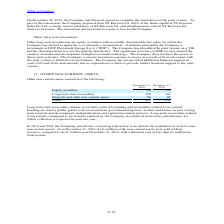According to Stmicroelectronics's financial document, How many non-current assets were sold without recourse as of December 31, 2019? According to the financial document, $131 million. The relevant text states: "some non-current assets. As at December 31, 2019, $131 million of the non-current assets were sold without recourse, compared to $122 million as at December 31, 20..." Also, How many non-current assets were sold without recourse as of December 31, 2018? According to the financial document, $122 million. The relevant text states: "ent assets were sold without recourse, compared to $122 million as at December 31, 2018, with a financial cost of less than $1 million for both periods...." Also, What does Long-term state receivables include? Long-term state receivables include receivables related to funding and receivables related to tax refund.. The document states: "Long-term state receivables include receivables related to funding and receivables related to tax refund. Funding are mainly public grants to be recei..." Also, can you calculate: What is the average Equity securities? To answer this question, I need to perform calculations using the financial data. The calculation is: (23+19) / 2, which equals 21 (in millions). This is based on the information: "Equity securities 23 19 Equity securities 23 19..." The key data points involved are: 19, 23. Also, can you calculate: What is the average Long-term state receivables? To answer this question, I need to perform calculations using the financial data. The calculation is: (358+391) / 2, which equals 374.5 (in millions). This is based on the information: "Long-term state receivables 358 391 Long-term state receivables 358 391..." The key data points involved are: 358, 391. Also, can you calculate: What is the average Deposits and other non-current assets? To answer this question, I need to perform calculations using the financial data. The calculation is: (56+42) / 2, which equals 49 (in millions). This is based on the information: "Deposits and other non-current assets 56 42 Deposits and other non-current assets 56 42..." The key data points involved are: 42, 56. 